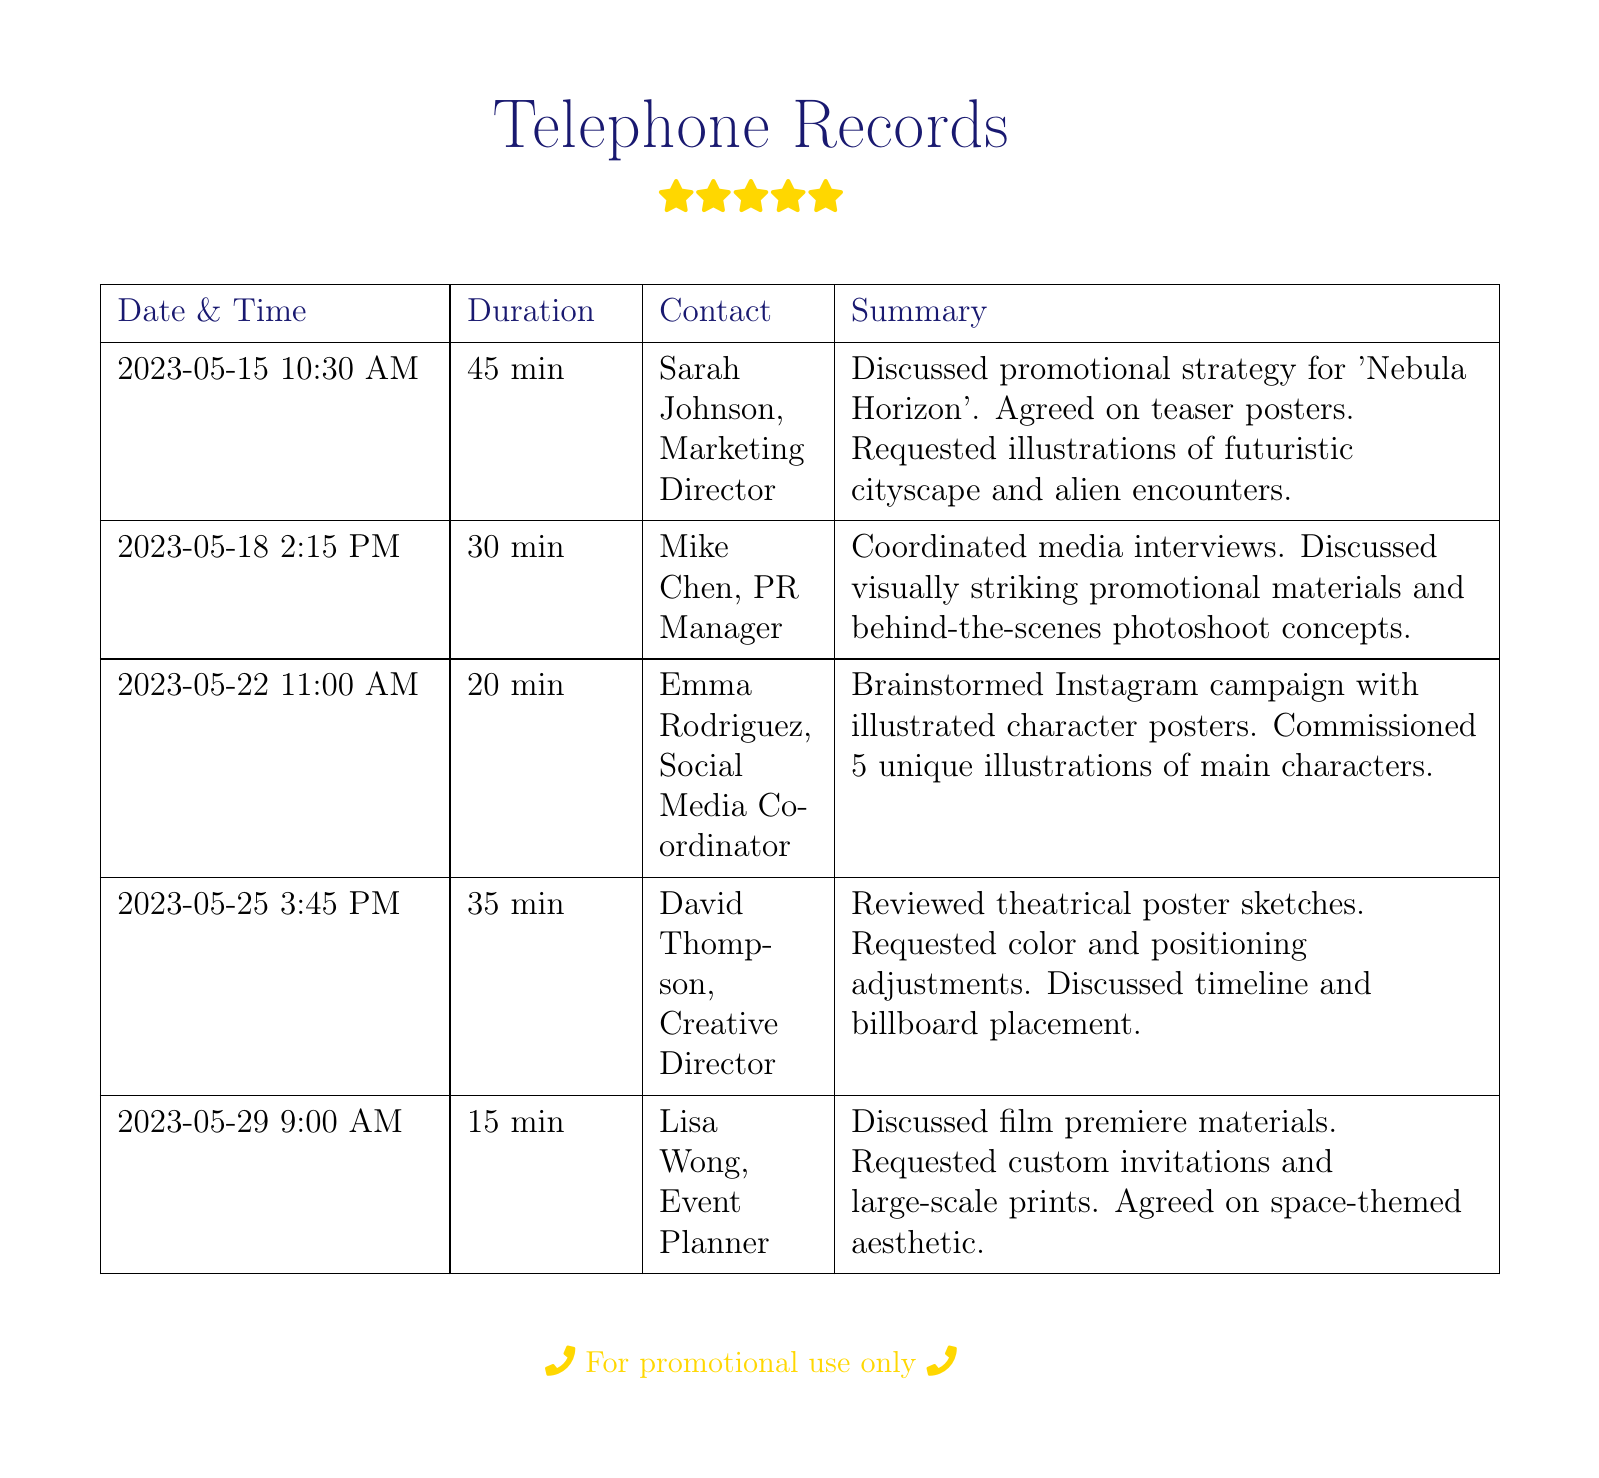What is the date of the first call? The first call took place on May 15, 2023.
Answer: May 15, 2023 Who did you speak with on May 22? On May 22, I spoke with Emma Rodriguez, the Social Media Coordinator.
Answer: Emma Rodriguez How long was the call with Mike Chen? The call with Mike Chen lasted 30 minutes.
Answer: 30 min What was discussed in the call on May 29? In the call on May 29, we discussed film premiere materials.
Answer: Film premiere materials How many illustrations were commissioned during the calls? A total of 6 unique illustrations were commissioned during the calls.
Answer: 6 What theme was agreed upon for the premiere materials? The theme agreed upon was space-themed.
Answer: Space-themed Who coordinated media interviews? Mike Chen, the PR Manager, coordinated media interviews.
Answer: Mike Chen What adjustments were requested for the theatrical poster sketches? Color and positioning adjustments were requested for the theatrical poster sketches.
Answer: Color and positioning adjustments 